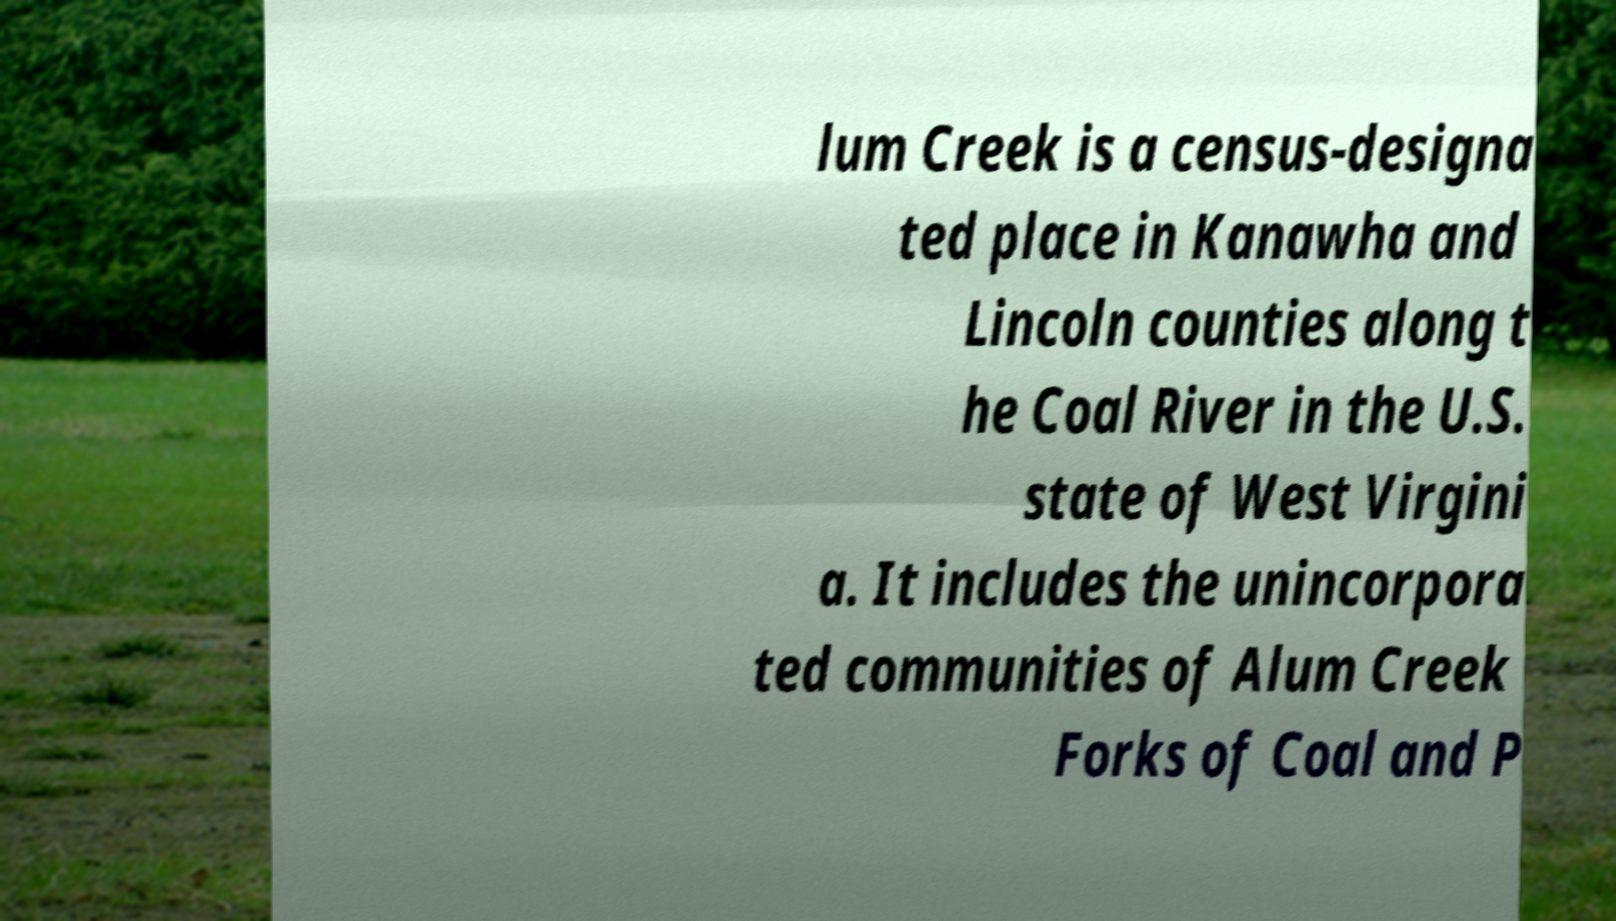I need the written content from this picture converted into text. Can you do that? lum Creek is a census-designa ted place in Kanawha and Lincoln counties along t he Coal River in the U.S. state of West Virgini a. It includes the unincorpora ted communities of Alum Creek Forks of Coal and P 